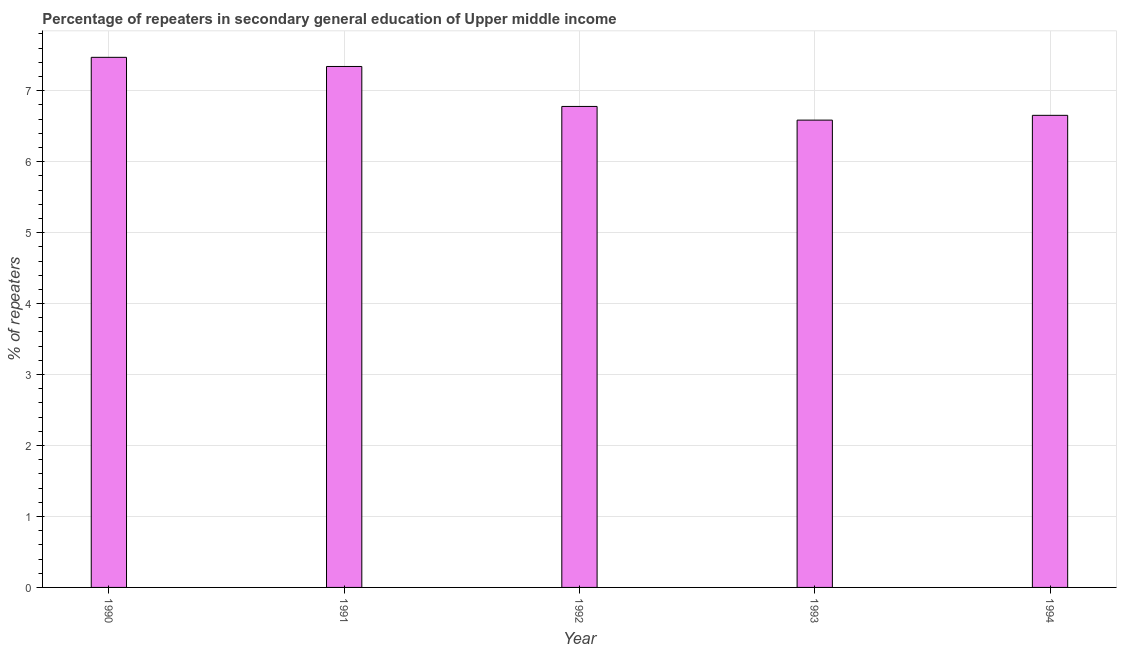Does the graph contain any zero values?
Give a very brief answer. No. What is the title of the graph?
Provide a short and direct response. Percentage of repeaters in secondary general education of Upper middle income. What is the label or title of the Y-axis?
Keep it short and to the point. % of repeaters. What is the percentage of repeaters in 1990?
Your answer should be very brief. 7.47. Across all years, what is the maximum percentage of repeaters?
Ensure brevity in your answer.  7.47. Across all years, what is the minimum percentage of repeaters?
Your answer should be compact. 6.59. In which year was the percentage of repeaters maximum?
Your answer should be very brief. 1990. In which year was the percentage of repeaters minimum?
Provide a short and direct response. 1993. What is the sum of the percentage of repeaters?
Offer a very short reply. 34.83. What is the difference between the percentage of repeaters in 1990 and 1991?
Offer a very short reply. 0.13. What is the average percentage of repeaters per year?
Provide a succinct answer. 6.97. What is the median percentage of repeaters?
Your answer should be very brief. 6.78. Do a majority of the years between 1992 and 1994 (inclusive) have percentage of repeaters greater than 6.2 %?
Ensure brevity in your answer.  Yes. What is the ratio of the percentage of repeaters in 1991 to that in 1993?
Your response must be concise. 1.11. What is the difference between the highest and the second highest percentage of repeaters?
Your response must be concise. 0.13. Is the sum of the percentage of repeaters in 1992 and 1993 greater than the maximum percentage of repeaters across all years?
Your answer should be very brief. Yes. What is the % of repeaters in 1990?
Your answer should be very brief. 7.47. What is the % of repeaters in 1991?
Provide a short and direct response. 7.34. What is the % of repeaters of 1992?
Offer a terse response. 6.78. What is the % of repeaters of 1993?
Your response must be concise. 6.59. What is the % of repeaters of 1994?
Provide a short and direct response. 6.65. What is the difference between the % of repeaters in 1990 and 1991?
Ensure brevity in your answer.  0.13. What is the difference between the % of repeaters in 1990 and 1992?
Keep it short and to the point. 0.69. What is the difference between the % of repeaters in 1990 and 1993?
Provide a succinct answer. 0.88. What is the difference between the % of repeaters in 1990 and 1994?
Your answer should be compact. 0.82. What is the difference between the % of repeaters in 1991 and 1992?
Your answer should be compact. 0.56. What is the difference between the % of repeaters in 1991 and 1993?
Your response must be concise. 0.76. What is the difference between the % of repeaters in 1991 and 1994?
Ensure brevity in your answer.  0.69. What is the difference between the % of repeaters in 1992 and 1993?
Provide a succinct answer. 0.19. What is the difference between the % of repeaters in 1992 and 1994?
Provide a succinct answer. 0.13. What is the difference between the % of repeaters in 1993 and 1994?
Provide a succinct answer. -0.07. What is the ratio of the % of repeaters in 1990 to that in 1991?
Make the answer very short. 1.02. What is the ratio of the % of repeaters in 1990 to that in 1992?
Make the answer very short. 1.1. What is the ratio of the % of repeaters in 1990 to that in 1993?
Give a very brief answer. 1.13. What is the ratio of the % of repeaters in 1990 to that in 1994?
Offer a very short reply. 1.12. What is the ratio of the % of repeaters in 1991 to that in 1992?
Your answer should be very brief. 1.08. What is the ratio of the % of repeaters in 1991 to that in 1993?
Ensure brevity in your answer.  1.11. What is the ratio of the % of repeaters in 1991 to that in 1994?
Keep it short and to the point. 1.1. 